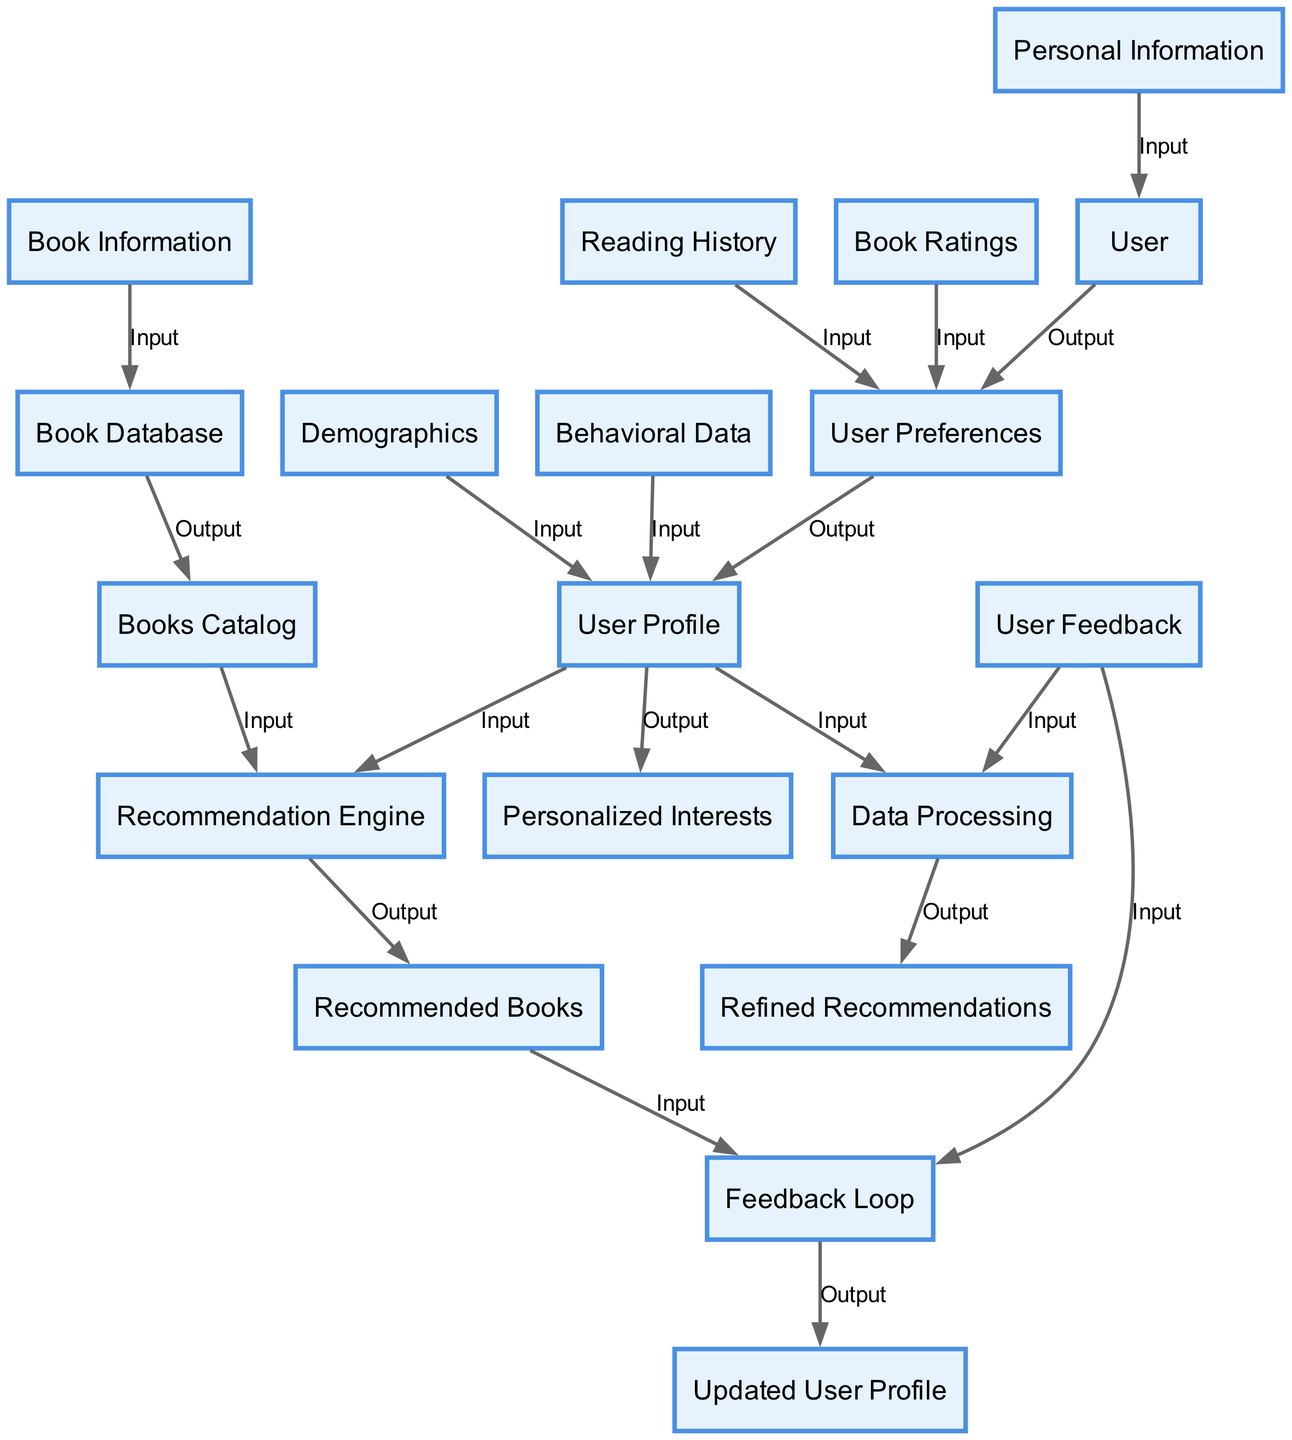What is the entity that generates user preferences? The entity that generates user preferences is the User. The diagram indicates that the User provides personal information, which then leads to the output of User Preferences.
Answer: User How many inputs does the User Profile entity have? The User Profile entity has two inputs: Demographics and Behavioral Data. This is derived from the diagram where the inputs to User Profile are clearly labeled as two distinct items.
Answer: 2 Which entity receives input from the Book Database? The entity that receives input from the Book Database is the Books Catalog. The diagram shows a directional flow where Book Information from the Book Database goes to the Books Catalog.
Answer: Books Catalog What type of data does the Recommendation Engine require? The Recommendation Engine requires User Profile and Books Catalog as its inputs. This is indicated in the diagram, showing the flow of these two inputs going to the Recommendation Engine.
Answer: User Profile and Books Catalog What is the output of the Data Processing entity? The output of the Data Processing entity is Refined Recommendations. Looking at the diagram, it is clear that this is the result of processing User Feedback and User Profile as its inputs.
Answer: Refined Recommendations What links the Recommended Books to the User Profile? The link that connects Recommended Books to the User Profile is through the Feedback Loop. This is shown in the diagram where User Feedback from the Recommended Books updates the User Profile.
Answer: Feedback Loop What is the relationship between User Preferences and User Profile? The relationship is that User Preferences serve as an input to generate the User Profile alongside Reading History and Book Ratings. This connection is visualized in the diagram, displaying the flow from User Preferences into the User Profile.
Answer: Input to User Profile How many outputs does the Recommendation Engine generate? The Recommendation Engine generates one output: Recommended Books. This is explicitly stated in the diagram as the singular output of the Recommendation Engine.
Answer: 1 Which element is primarily concerned with feedback? The element primarily concerned with feedback is the Feedback Loop. The diagram demonstrates the flow of User Feedback being utilized to update the User Profile through this Feedback Loop.
Answer: Feedback Loop 